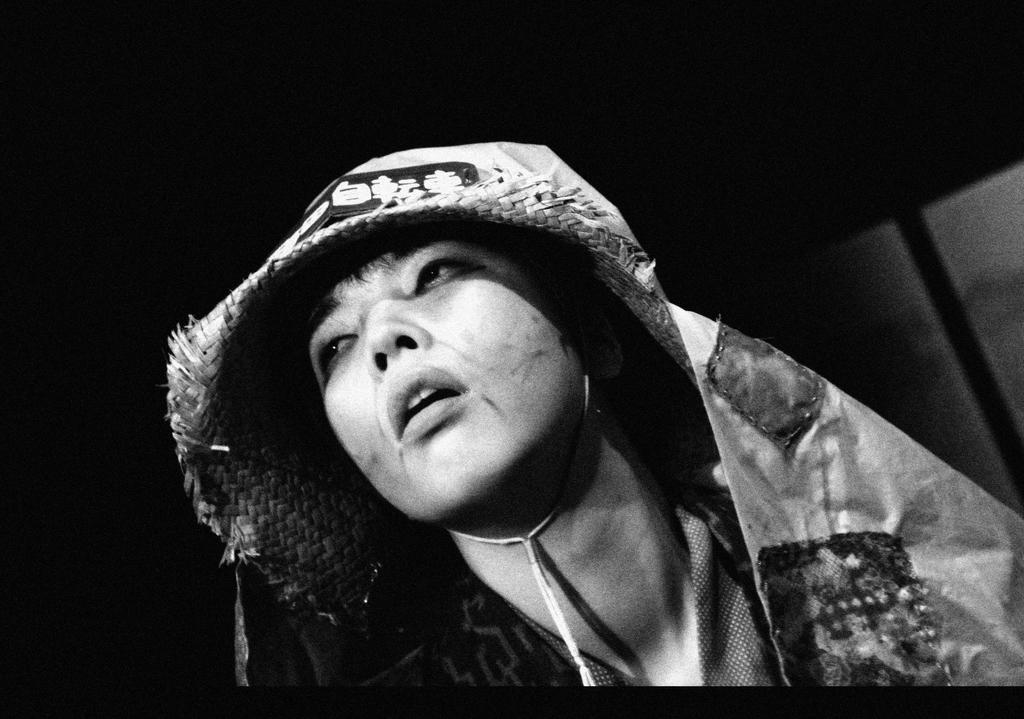What is the color scheme of the image? The image is black and white. Can you describe the person in the image? There is a person in the image, and they have a cloth on their head. What can be observed about the background of the image? The background of the image appears dark. What type of cork can be seen in the person's hand in the image? There is no cork present in the image; the person has a cloth on their head. What channel is the person watching in the image? There is no television or channel visible in the image. 